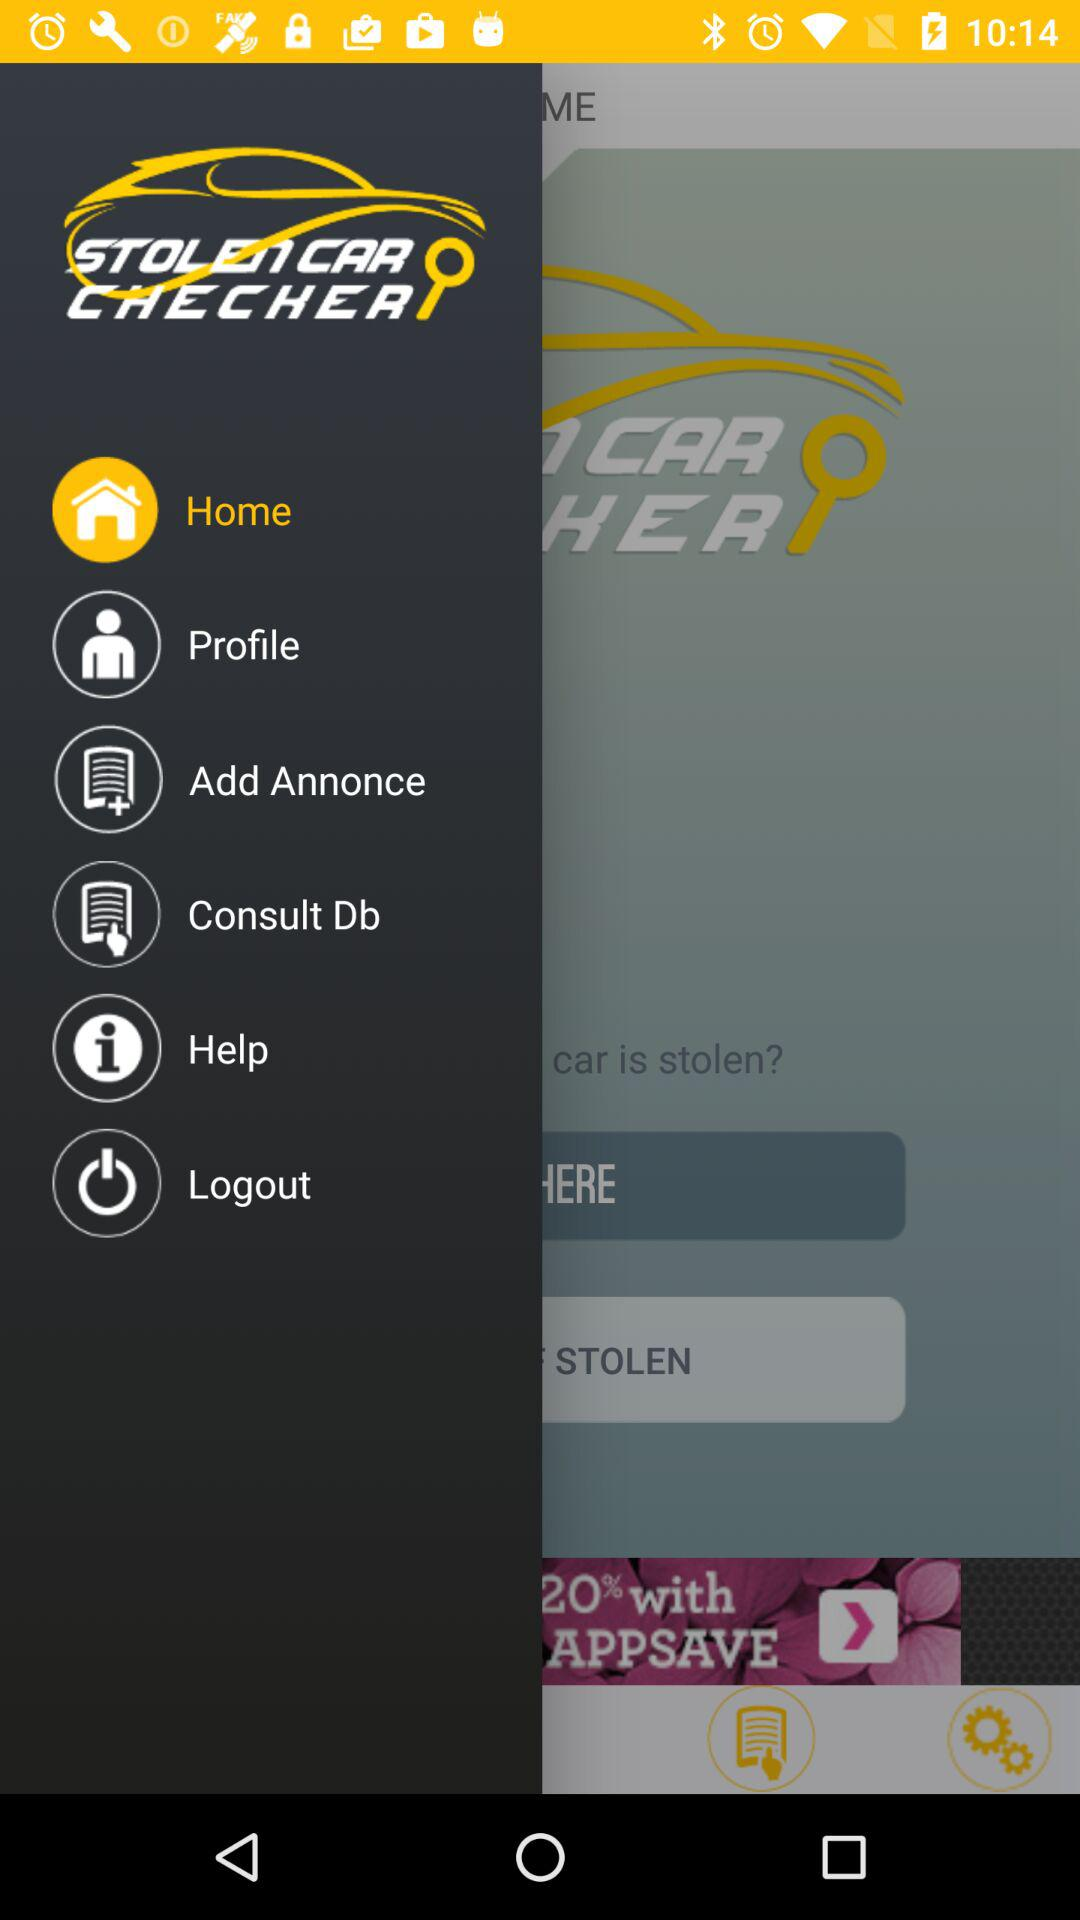What is the name of the application? The name of the application is "STOLEN CAR CHECHER". 